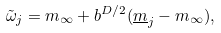Convert formula to latex. <formula><loc_0><loc_0><loc_500><loc_500>\tilde { \omega } _ { j } = m _ { \infty } + b ^ { D / 2 } ( \underline { m } _ { j } - m _ { \infty } ) ,</formula> 